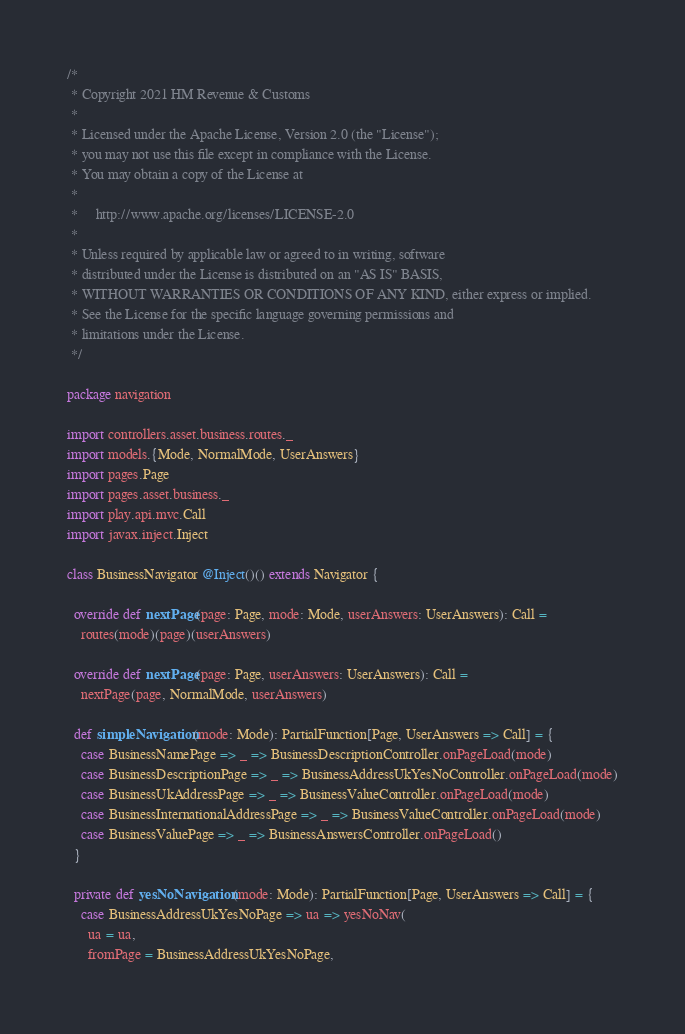<code> <loc_0><loc_0><loc_500><loc_500><_Scala_>/*
 * Copyright 2021 HM Revenue & Customs
 *
 * Licensed under the Apache License, Version 2.0 (the "License");
 * you may not use this file except in compliance with the License.
 * You may obtain a copy of the License at
 *
 *     http://www.apache.org/licenses/LICENSE-2.0
 *
 * Unless required by applicable law or agreed to in writing, software
 * distributed under the License is distributed on an "AS IS" BASIS,
 * WITHOUT WARRANTIES OR CONDITIONS OF ANY KIND, either express or implied.
 * See the License for the specific language governing permissions and
 * limitations under the License.
 */

package navigation

import controllers.asset.business.routes._
import models.{Mode, NormalMode, UserAnswers}
import pages.Page
import pages.asset.business._
import play.api.mvc.Call
import javax.inject.Inject

class BusinessNavigator @Inject()() extends Navigator {

  override def nextPage(page: Page, mode: Mode, userAnswers: UserAnswers): Call =
    routes(mode)(page)(userAnswers)

  override def nextPage(page: Page, userAnswers: UserAnswers): Call =
    nextPage(page, NormalMode, userAnswers)

  def simpleNavigation(mode: Mode): PartialFunction[Page, UserAnswers => Call] = {
    case BusinessNamePage => _ => BusinessDescriptionController.onPageLoad(mode)
    case BusinessDescriptionPage => _ => BusinessAddressUkYesNoController.onPageLoad(mode)
    case BusinessUkAddressPage => _ => BusinessValueController.onPageLoad(mode)
    case BusinessInternationalAddressPage => _ => BusinessValueController.onPageLoad(mode)
    case BusinessValuePage => _ => BusinessAnswersController.onPageLoad()
  }

  private def yesNoNavigation(mode: Mode): PartialFunction[Page, UserAnswers => Call] = {
    case BusinessAddressUkYesNoPage => ua => yesNoNav(
      ua = ua,
      fromPage = BusinessAddressUkYesNoPage,</code> 